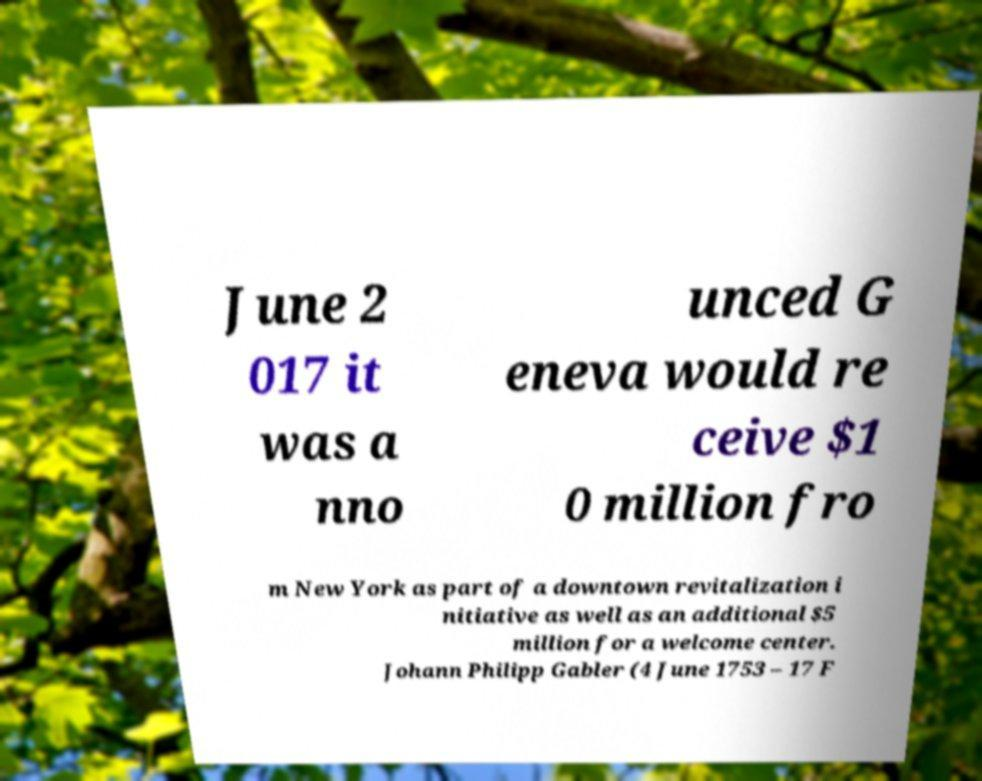Could you assist in decoding the text presented in this image and type it out clearly? June 2 017 it was a nno unced G eneva would re ceive $1 0 million fro m New York as part of a downtown revitalization i nitiative as well as an additional $5 million for a welcome center. Johann Philipp Gabler (4 June 1753 – 17 F 